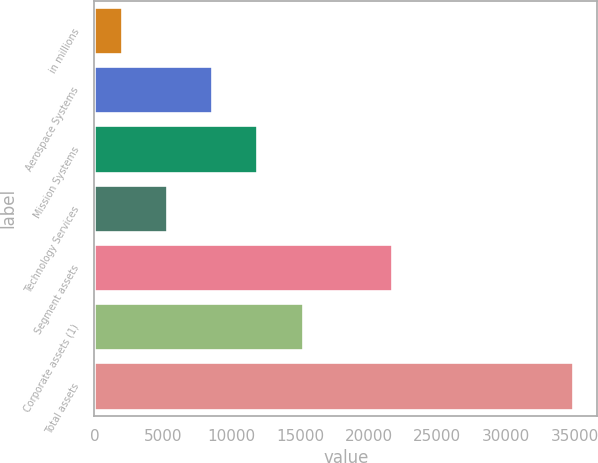<chart> <loc_0><loc_0><loc_500><loc_500><bar_chart><fcel>in millions<fcel>Aerospace Systems<fcel>Mission Systems<fcel>Technology Services<fcel>Segment assets<fcel>Corporate assets (1)<fcel>Total assets<nl><fcel>2017<fcel>8597<fcel>11887<fcel>5307<fcel>21663<fcel>15177<fcel>34917<nl></chart> 